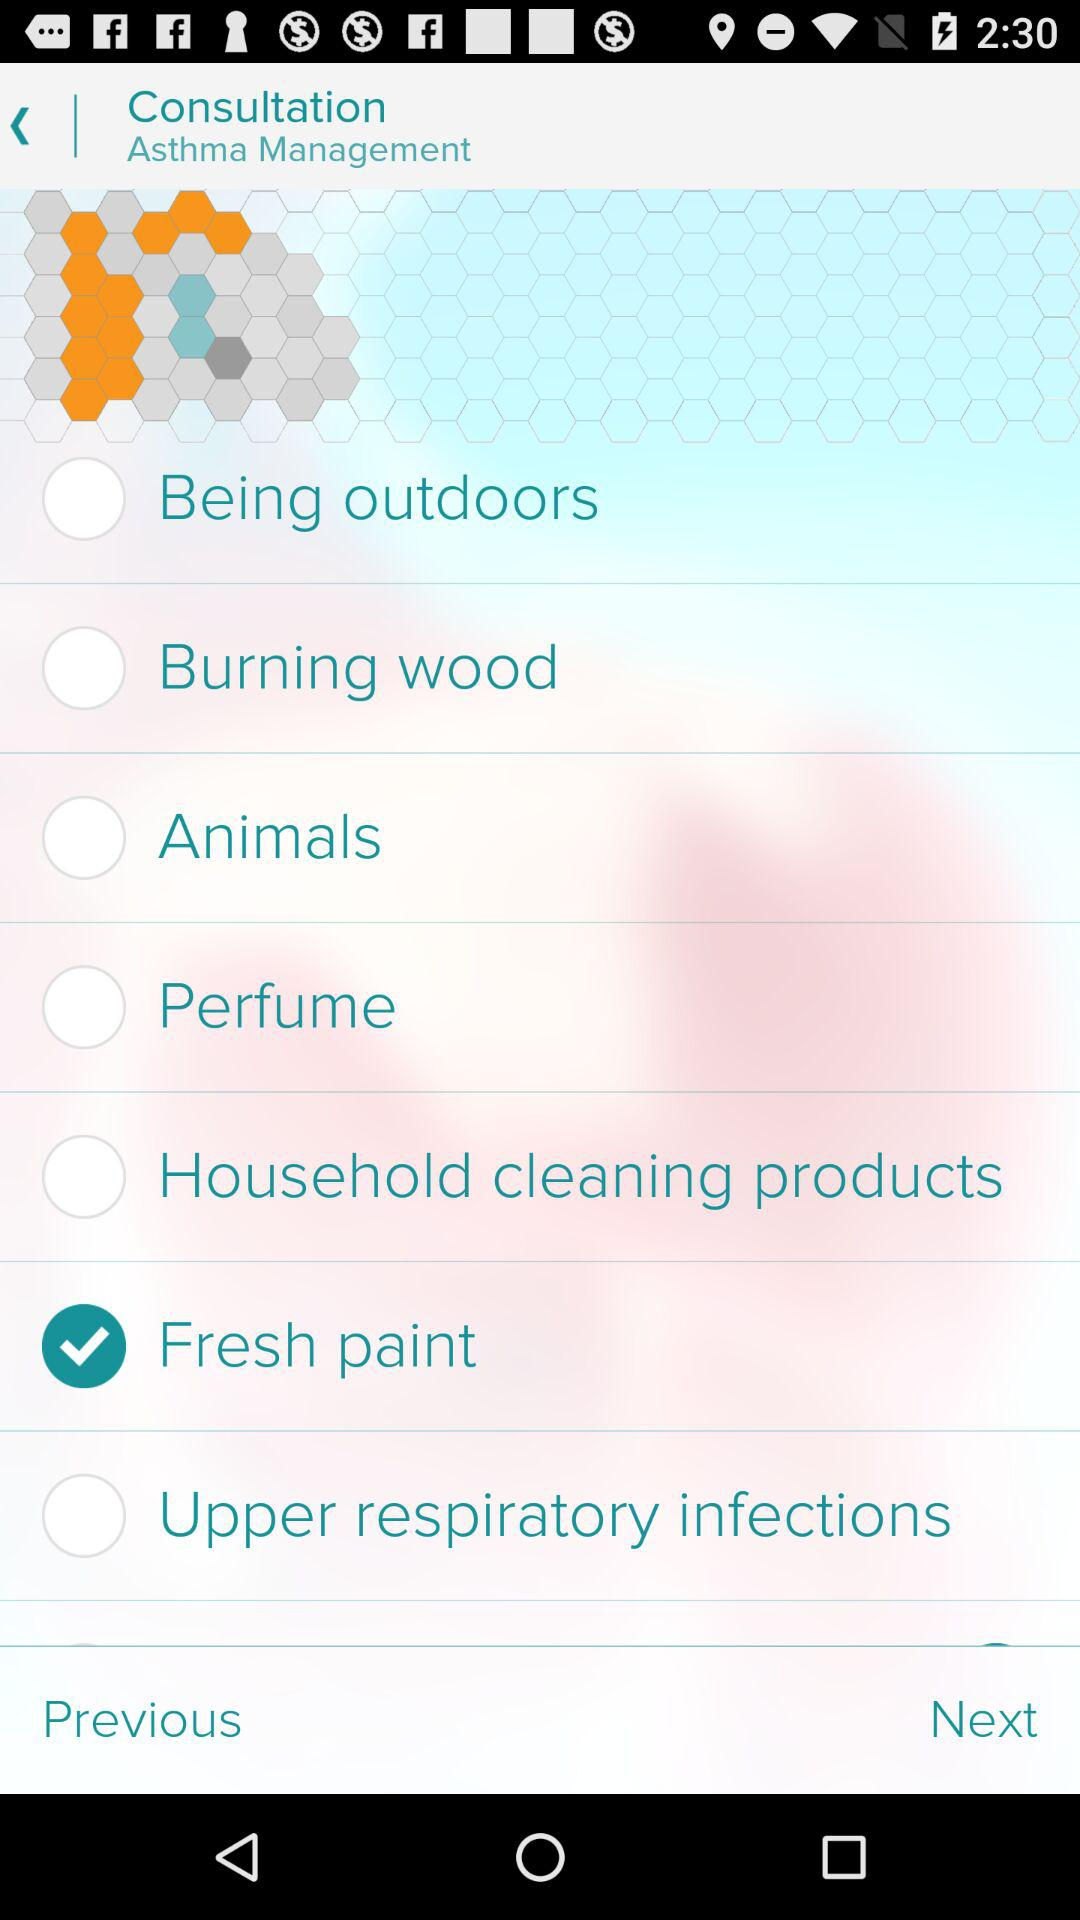Which option is marked as checked? The option that is marked as checked is "Fresh paint". 